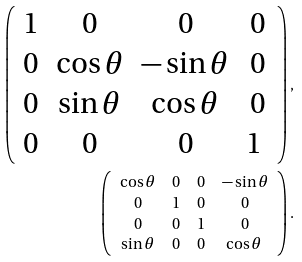<formula> <loc_0><loc_0><loc_500><loc_500>\left ( \begin{array} { c c c c } 1 & 0 & 0 & 0 \\ 0 & \cos \theta & - \sin \theta & 0 \\ 0 & \sin \theta & \cos \theta & 0 \\ 0 & 0 & 0 & 1 \ \end{array} \right ) , \\ \left ( \begin{array} { c c c c } \cos \theta & 0 & 0 & - \sin \theta \\ 0 & 1 & 0 & 0 \\ 0 & 0 & 1 & 0 \\ \sin \theta & 0 & 0 & \cos \theta \ \end{array} \right ) .</formula> 